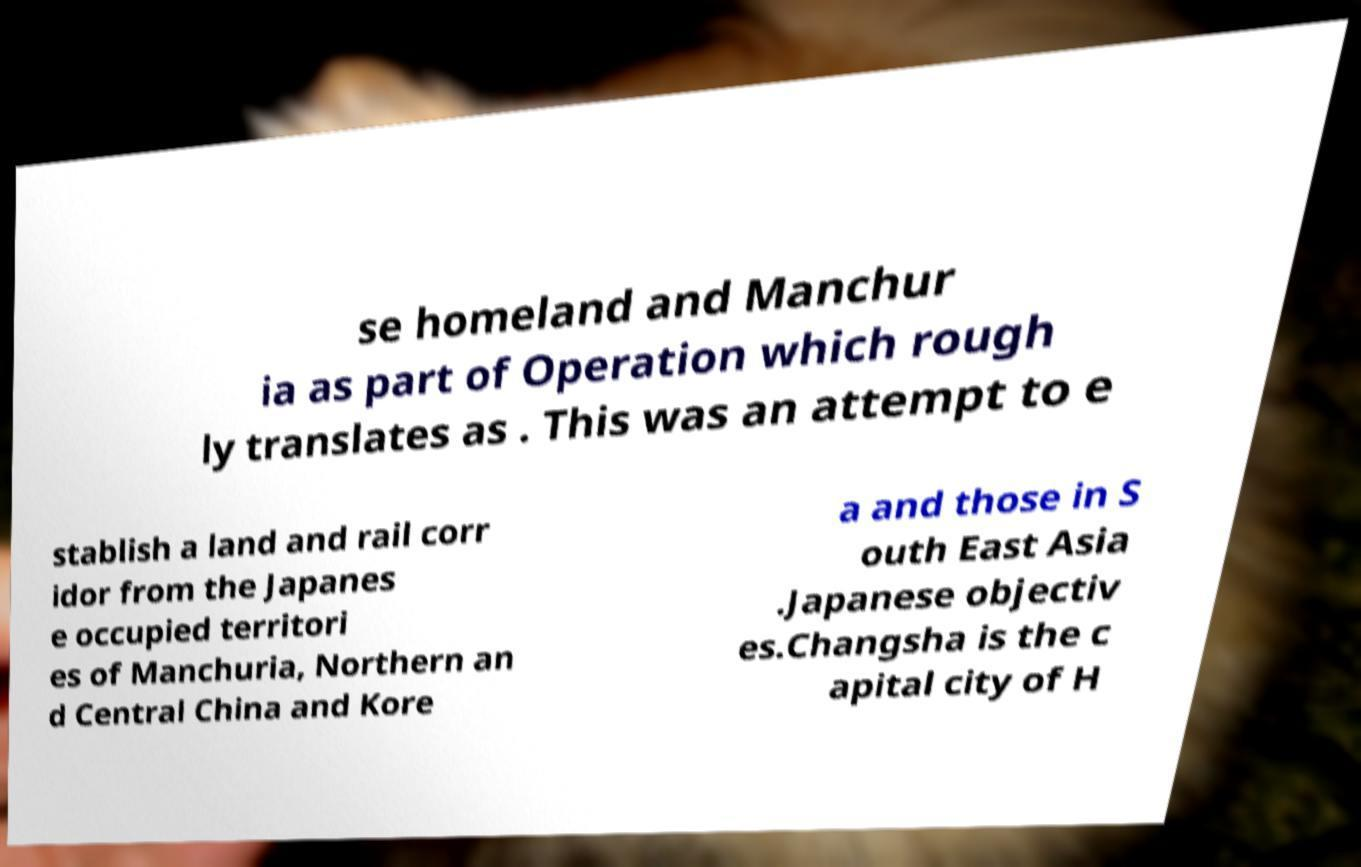Please read and relay the text visible in this image. What does it say? se homeland and Manchur ia as part of Operation which rough ly translates as . This was an attempt to e stablish a land and rail corr idor from the Japanes e occupied territori es of Manchuria, Northern an d Central China and Kore a and those in S outh East Asia .Japanese objectiv es.Changsha is the c apital city of H 